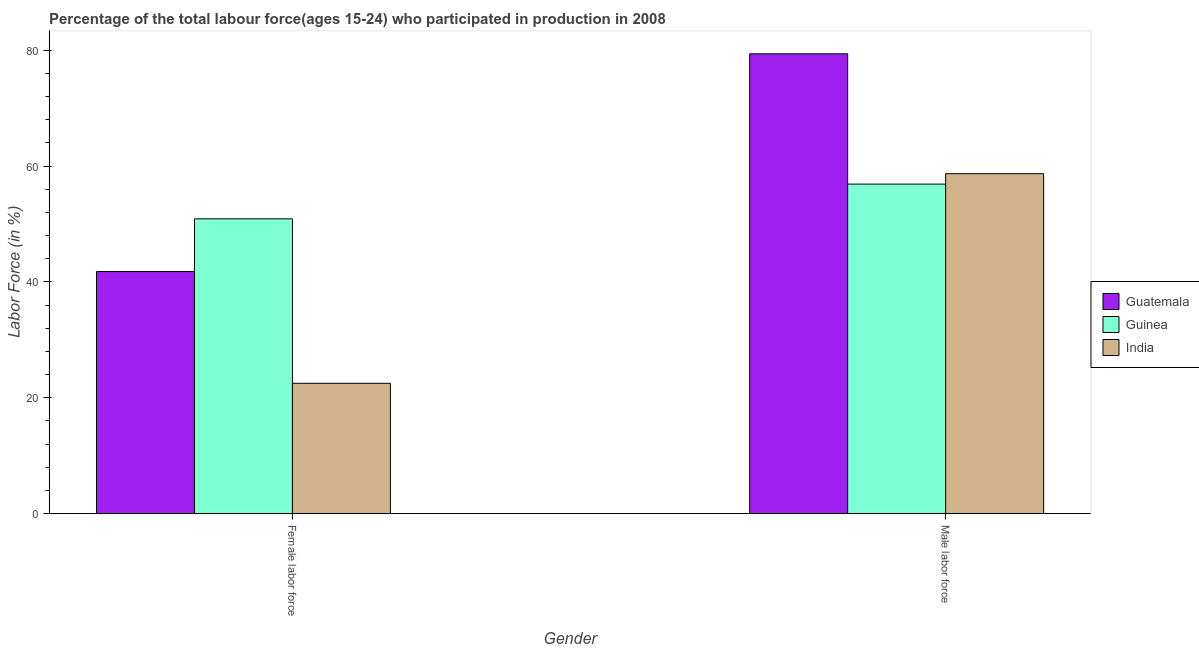How many groups of bars are there?
Your answer should be compact. 2. Are the number of bars per tick equal to the number of legend labels?
Offer a terse response. Yes. Are the number of bars on each tick of the X-axis equal?
Ensure brevity in your answer.  Yes. How many bars are there on the 1st tick from the right?
Keep it short and to the point. 3. What is the label of the 1st group of bars from the left?
Your answer should be compact. Female labor force. What is the percentage of female labor force in India?
Provide a succinct answer. 22.5. Across all countries, what is the maximum percentage of male labour force?
Ensure brevity in your answer.  79.4. In which country was the percentage of female labor force maximum?
Your response must be concise. Guinea. What is the total percentage of male labour force in the graph?
Keep it short and to the point. 195. What is the difference between the percentage of female labor force in Guinea and that in India?
Provide a short and direct response. 28.4. What is the difference between the percentage of male labour force in Guatemala and the percentage of female labor force in India?
Offer a very short reply. 56.9. What is the average percentage of male labour force per country?
Provide a short and direct response. 65. What is the difference between the percentage of female labor force and percentage of male labour force in India?
Offer a very short reply. -36.2. What is the ratio of the percentage of female labor force in Guinea to that in Guatemala?
Make the answer very short. 1.22. Is the percentage of female labor force in India less than that in Guinea?
Your answer should be very brief. Yes. What does the 2nd bar from the left in Female labor force represents?
Offer a terse response. Guinea. What does the 3rd bar from the right in Male labor force represents?
Your answer should be very brief. Guatemala. What is the difference between two consecutive major ticks on the Y-axis?
Your answer should be very brief. 20. Are the values on the major ticks of Y-axis written in scientific E-notation?
Give a very brief answer. No. Does the graph contain any zero values?
Give a very brief answer. No. Where does the legend appear in the graph?
Offer a very short reply. Center right. How many legend labels are there?
Keep it short and to the point. 3. What is the title of the graph?
Provide a short and direct response. Percentage of the total labour force(ages 15-24) who participated in production in 2008. Does "Azerbaijan" appear as one of the legend labels in the graph?
Provide a succinct answer. No. What is the label or title of the X-axis?
Ensure brevity in your answer.  Gender. What is the Labor Force (in %) of Guatemala in Female labor force?
Provide a short and direct response. 41.8. What is the Labor Force (in %) of Guinea in Female labor force?
Give a very brief answer. 50.9. What is the Labor Force (in %) of Guatemala in Male labor force?
Ensure brevity in your answer.  79.4. What is the Labor Force (in %) in Guinea in Male labor force?
Your response must be concise. 56.9. What is the Labor Force (in %) in India in Male labor force?
Ensure brevity in your answer.  58.7. Across all Gender, what is the maximum Labor Force (in %) in Guatemala?
Provide a short and direct response. 79.4. Across all Gender, what is the maximum Labor Force (in %) in Guinea?
Give a very brief answer. 56.9. Across all Gender, what is the maximum Labor Force (in %) in India?
Your answer should be very brief. 58.7. Across all Gender, what is the minimum Labor Force (in %) in Guatemala?
Provide a succinct answer. 41.8. Across all Gender, what is the minimum Labor Force (in %) of Guinea?
Your answer should be compact. 50.9. What is the total Labor Force (in %) of Guatemala in the graph?
Offer a terse response. 121.2. What is the total Labor Force (in %) in Guinea in the graph?
Your answer should be compact. 107.8. What is the total Labor Force (in %) in India in the graph?
Make the answer very short. 81.2. What is the difference between the Labor Force (in %) of Guatemala in Female labor force and that in Male labor force?
Provide a succinct answer. -37.6. What is the difference between the Labor Force (in %) of India in Female labor force and that in Male labor force?
Provide a short and direct response. -36.2. What is the difference between the Labor Force (in %) of Guatemala in Female labor force and the Labor Force (in %) of Guinea in Male labor force?
Your answer should be very brief. -15.1. What is the difference between the Labor Force (in %) of Guatemala in Female labor force and the Labor Force (in %) of India in Male labor force?
Provide a succinct answer. -16.9. What is the difference between the Labor Force (in %) of Guinea in Female labor force and the Labor Force (in %) of India in Male labor force?
Provide a succinct answer. -7.8. What is the average Labor Force (in %) in Guatemala per Gender?
Your response must be concise. 60.6. What is the average Labor Force (in %) in Guinea per Gender?
Make the answer very short. 53.9. What is the average Labor Force (in %) in India per Gender?
Give a very brief answer. 40.6. What is the difference between the Labor Force (in %) of Guatemala and Labor Force (in %) of India in Female labor force?
Your response must be concise. 19.3. What is the difference between the Labor Force (in %) of Guinea and Labor Force (in %) of India in Female labor force?
Make the answer very short. 28.4. What is the difference between the Labor Force (in %) of Guatemala and Labor Force (in %) of India in Male labor force?
Give a very brief answer. 20.7. What is the ratio of the Labor Force (in %) in Guatemala in Female labor force to that in Male labor force?
Ensure brevity in your answer.  0.53. What is the ratio of the Labor Force (in %) in Guinea in Female labor force to that in Male labor force?
Provide a succinct answer. 0.89. What is the ratio of the Labor Force (in %) in India in Female labor force to that in Male labor force?
Your response must be concise. 0.38. What is the difference between the highest and the second highest Labor Force (in %) of Guatemala?
Offer a terse response. 37.6. What is the difference between the highest and the second highest Labor Force (in %) in India?
Keep it short and to the point. 36.2. What is the difference between the highest and the lowest Labor Force (in %) in Guatemala?
Make the answer very short. 37.6. What is the difference between the highest and the lowest Labor Force (in %) of India?
Your answer should be compact. 36.2. 